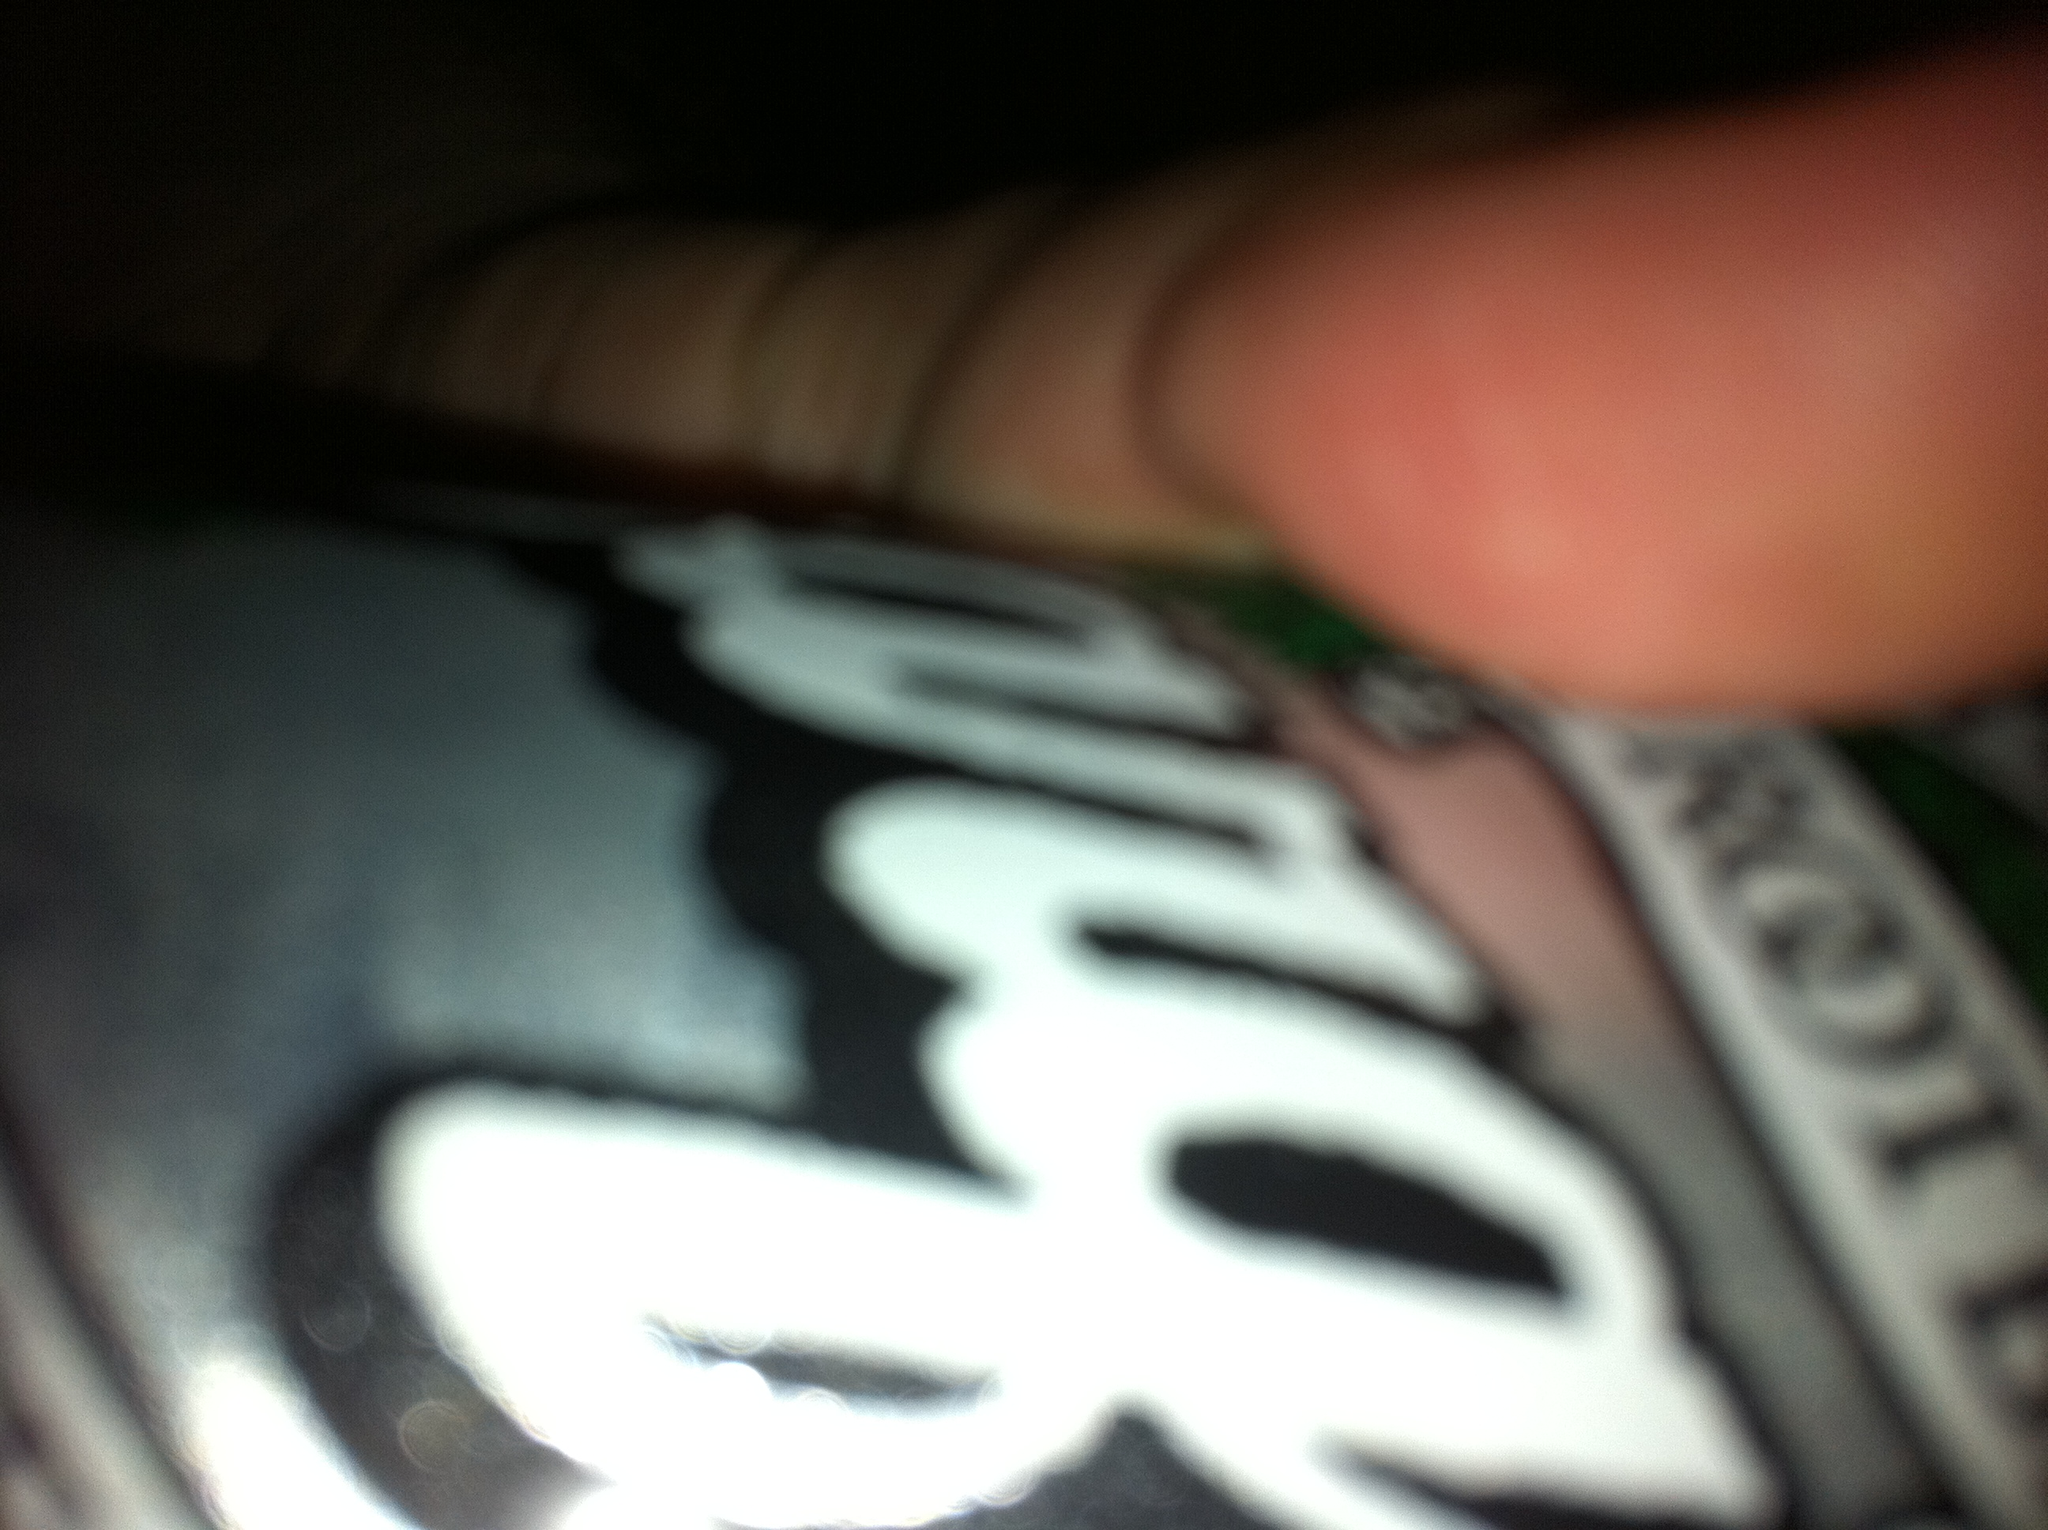What brand of root beer is this? Judging by the design and logo on the can, it looks like A&W Root Beer, a popular brand known for its rich and creamy taste. 